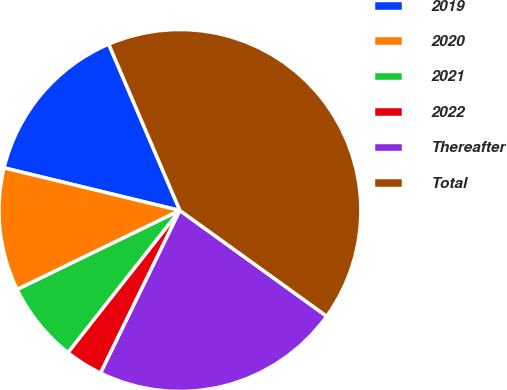<chart> <loc_0><loc_0><loc_500><loc_500><pie_chart><fcel>2019<fcel>2020<fcel>2021<fcel>2022<fcel>Thereafter<fcel>Total<nl><fcel>14.78%<fcel>10.98%<fcel>7.19%<fcel>3.39%<fcel>22.29%<fcel>41.37%<nl></chart> 